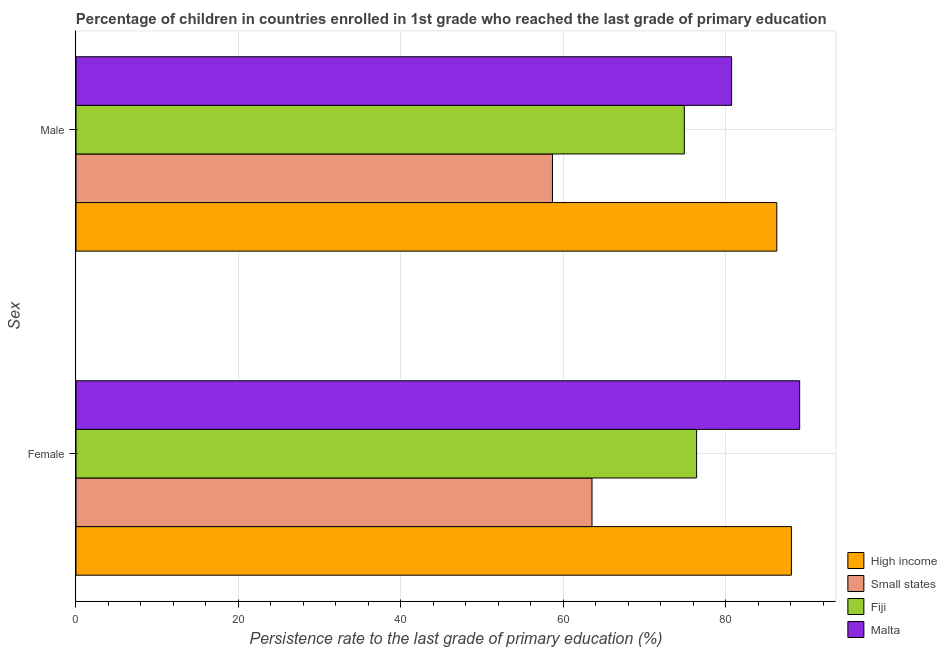How many different coloured bars are there?
Provide a succinct answer. 4. Are the number of bars per tick equal to the number of legend labels?
Offer a terse response. Yes. How many bars are there on the 2nd tick from the bottom?
Provide a short and direct response. 4. What is the persistence rate of male students in Malta?
Your answer should be compact. 80.74. Across all countries, what is the maximum persistence rate of male students?
Ensure brevity in your answer.  86.3. Across all countries, what is the minimum persistence rate of female students?
Provide a short and direct response. 63.54. In which country was the persistence rate of male students maximum?
Provide a succinct answer. High income. In which country was the persistence rate of male students minimum?
Your answer should be very brief. Small states. What is the total persistence rate of male students in the graph?
Your response must be concise. 300.63. What is the difference between the persistence rate of female students in Fiji and that in Small states?
Offer a very short reply. 12.88. What is the difference between the persistence rate of male students in Fiji and the persistence rate of female students in Small states?
Offer a very short reply. 11.37. What is the average persistence rate of male students per country?
Your answer should be very brief. 75.16. What is the difference between the persistence rate of male students and persistence rate of female students in Malta?
Your answer should be very brief. -8.38. In how many countries, is the persistence rate of female students greater than 56 %?
Ensure brevity in your answer.  4. What is the ratio of the persistence rate of male students in High income to that in Small states?
Keep it short and to the point. 1.47. In how many countries, is the persistence rate of female students greater than the average persistence rate of female students taken over all countries?
Provide a short and direct response. 2. What does the 2nd bar from the bottom in Female represents?
Provide a succinct answer. Small states. How many bars are there?
Provide a succinct answer. 8. How many countries are there in the graph?
Offer a terse response. 4. What is the difference between two consecutive major ticks on the X-axis?
Offer a very short reply. 20. Does the graph contain any zero values?
Provide a succinct answer. No. Where does the legend appear in the graph?
Your answer should be compact. Bottom right. How many legend labels are there?
Your answer should be compact. 4. How are the legend labels stacked?
Provide a short and direct response. Vertical. What is the title of the graph?
Your response must be concise. Percentage of children in countries enrolled in 1st grade who reached the last grade of primary education. What is the label or title of the X-axis?
Ensure brevity in your answer.  Persistence rate to the last grade of primary education (%). What is the label or title of the Y-axis?
Make the answer very short. Sex. What is the Persistence rate to the last grade of primary education (%) of High income in Female?
Your answer should be compact. 88.1. What is the Persistence rate to the last grade of primary education (%) of Small states in Female?
Provide a short and direct response. 63.54. What is the Persistence rate to the last grade of primary education (%) in Fiji in Female?
Provide a short and direct response. 76.43. What is the Persistence rate to the last grade of primary education (%) in Malta in Female?
Ensure brevity in your answer.  89.12. What is the Persistence rate to the last grade of primary education (%) in High income in Male?
Ensure brevity in your answer.  86.3. What is the Persistence rate to the last grade of primary education (%) of Small states in Male?
Give a very brief answer. 58.68. What is the Persistence rate to the last grade of primary education (%) in Fiji in Male?
Keep it short and to the point. 74.91. What is the Persistence rate to the last grade of primary education (%) of Malta in Male?
Ensure brevity in your answer.  80.74. Across all Sex, what is the maximum Persistence rate to the last grade of primary education (%) in High income?
Make the answer very short. 88.1. Across all Sex, what is the maximum Persistence rate to the last grade of primary education (%) in Small states?
Offer a very short reply. 63.54. Across all Sex, what is the maximum Persistence rate to the last grade of primary education (%) of Fiji?
Your response must be concise. 76.43. Across all Sex, what is the maximum Persistence rate to the last grade of primary education (%) of Malta?
Give a very brief answer. 89.12. Across all Sex, what is the minimum Persistence rate to the last grade of primary education (%) in High income?
Provide a succinct answer. 86.3. Across all Sex, what is the minimum Persistence rate to the last grade of primary education (%) in Small states?
Provide a short and direct response. 58.68. Across all Sex, what is the minimum Persistence rate to the last grade of primary education (%) of Fiji?
Your answer should be compact. 74.91. Across all Sex, what is the minimum Persistence rate to the last grade of primary education (%) in Malta?
Provide a succinct answer. 80.74. What is the total Persistence rate to the last grade of primary education (%) in High income in the graph?
Make the answer very short. 174.4. What is the total Persistence rate to the last grade of primary education (%) in Small states in the graph?
Offer a very short reply. 122.22. What is the total Persistence rate to the last grade of primary education (%) in Fiji in the graph?
Offer a terse response. 151.34. What is the total Persistence rate to the last grade of primary education (%) in Malta in the graph?
Your answer should be very brief. 169.85. What is the difference between the Persistence rate to the last grade of primary education (%) of High income in Female and that in Male?
Your answer should be compact. 1.8. What is the difference between the Persistence rate to the last grade of primary education (%) of Small states in Female and that in Male?
Offer a very short reply. 4.87. What is the difference between the Persistence rate to the last grade of primary education (%) in Fiji in Female and that in Male?
Your response must be concise. 1.51. What is the difference between the Persistence rate to the last grade of primary education (%) in Malta in Female and that in Male?
Give a very brief answer. 8.38. What is the difference between the Persistence rate to the last grade of primary education (%) in High income in Female and the Persistence rate to the last grade of primary education (%) in Small states in Male?
Provide a succinct answer. 29.42. What is the difference between the Persistence rate to the last grade of primary education (%) in High income in Female and the Persistence rate to the last grade of primary education (%) in Fiji in Male?
Give a very brief answer. 13.19. What is the difference between the Persistence rate to the last grade of primary education (%) in High income in Female and the Persistence rate to the last grade of primary education (%) in Malta in Male?
Your answer should be very brief. 7.36. What is the difference between the Persistence rate to the last grade of primary education (%) in Small states in Female and the Persistence rate to the last grade of primary education (%) in Fiji in Male?
Offer a terse response. -11.37. What is the difference between the Persistence rate to the last grade of primary education (%) in Small states in Female and the Persistence rate to the last grade of primary education (%) in Malta in Male?
Provide a succinct answer. -17.19. What is the difference between the Persistence rate to the last grade of primary education (%) in Fiji in Female and the Persistence rate to the last grade of primary education (%) in Malta in Male?
Offer a very short reply. -4.31. What is the average Persistence rate to the last grade of primary education (%) in High income per Sex?
Keep it short and to the point. 87.2. What is the average Persistence rate to the last grade of primary education (%) in Small states per Sex?
Your response must be concise. 61.11. What is the average Persistence rate to the last grade of primary education (%) in Fiji per Sex?
Your response must be concise. 75.67. What is the average Persistence rate to the last grade of primary education (%) of Malta per Sex?
Your answer should be very brief. 84.93. What is the difference between the Persistence rate to the last grade of primary education (%) of High income and Persistence rate to the last grade of primary education (%) of Small states in Female?
Provide a short and direct response. 24.55. What is the difference between the Persistence rate to the last grade of primary education (%) in High income and Persistence rate to the last grade of primary education (%) in Fiji in Female?
Keep it short and to the point. 11.67. What is the difference between the Persistence rate to the last grade of primary education (%) of High income and Persistence rate to the last grade of primary education (%) of Malta in Female?
Keep it short and to the point. -1.02. What is the difference between the Persistence rate to the last grade of primary education (%) in Small states and Persistence rate to the last grade of primary education (%) in Fiji in Female?
Provide a succinct answer. -12.88. What is the difference between the Persistence rate to the last grade of primary education (%) of Small states and Persistence rate to the last grade of primary education (%) of Malta in Female?
Give a very brief answer. -25.57. What is the difference between the Persistence rate to the last grade of primary education (%) in Fiji and Persistence rate to the last grade of primary education (%) in Malta in Female?
Offer a very short reply. -12.69. What is the difference between the Persistence rate to the last grade of primary education (%) of High income and Persistence rate to the last grade of primary education (%) of Small states in Male?
Give a very brief answer. 27.62. What is the difference between the Persistence rate to the last grade of primary education (%) of High income and Persistence rate to the last grade of primary education (%) of Fiji in Male?
Give a very brief answer. 11.39. What is the difference between the Persistence rate to the last grade of primary education (%) of High income and Persistence rate to the last grade of primary education (%) of Malta in Male?
Offer a terse response. 5.56. What is the difference between the Persistence rate to the last grade of primary education (%) of Small states and Persistence rate to the last grade of primary education (%) of Fiji in Male?
Your answer should be very brief. -16.24. What is the difference between the Persistence rate to the last grade of primary education (%) in Small states and Persistence rate to the last grade of primary education (%) in Malta in Male?
Offer a terse response. -22.06. What is the difference between the Persistence rate to the last grade of primary education (%) in Fiji and Persistence rate to the last grade of primary education (%) in Malta in Male?
Offer a terse response. -5.82. What is the ratio of the Persistence rate to the last grade of primary education (%) in High income in Female to that in Male?
Your response must be concise. 1.02. What is the ratio of the Persistence rate to the last grade of primary education (%) of Small states in Female to that in Male?
Provide a succinct answer. 1.08. What is the ratio of the Persistence rate to the last grade of primary education (%) in Fiji in Female to that in Male?
Ensure brevity in your answer.  1.02. What is the ratio of the Persistence rate to the last grade of primary education (%) in Malta in Female to that in Male?
Provide a succinct answer. 1.1. What is the difference between the highest and the second highest Persistence rate to the last grade of primary education (%) in High income?
Make the answer very short. 1.8. What is the difference between the highest and the second highest Persistence rate to the last grade of primary education (%) in Small states?
Offer a terse response. 4.87. What is the difference between the highest and the second highest Persistence rate to the last grade of primary education (%) in Fiji?
Your answer should be very brief. 1.51. What is the difference between the highest and the second highest Persistence rate to the last grade of primary education (%) in Malta?
Your response must be concise. 8.38. What is the difference between the highest and the lowest Persistence rate to the last grade of primary education (%) in High income?
Ensure brevity in your answer.  1.8. What is the difference between the highest and the lowest Persistence rate to the last grade of primary education (%) of Small states?
Your response must be concise. 4.87. What is the difference between the highest and the lowest Persistence rate to the last grade of primary education (%) in Fiji?
Offer a terse response. 1.51. What is the difference between the highest and the lowest Persistence rate to the last grade of primary education (%) in Malta?
Keep it short and to the point. 8.38. 